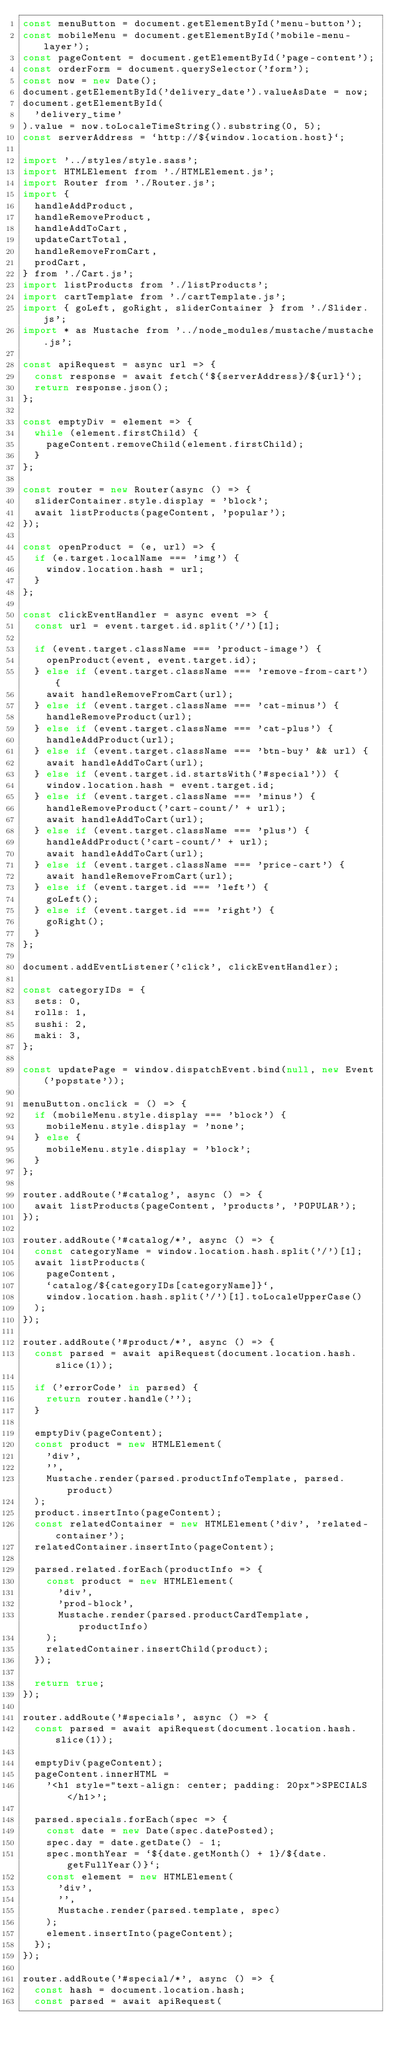<code> <loc_0><loc_0><loc_500><loc_500><_JavaScript_>const menuButton = document.getElementById('menu-button');
const mobileMenu = document.getElementById('mobile-menu-layer');
const pageContent = document.getElementById('page-content');
const orderForm = document.querySelector('form');
const now = new Date();
document.getElementById('delivery_date').valueAsDate = now;
document.getElementById(
  'delivery_time'
).value = now.toLocaleTimeString().substring(0, 5);
const serverAddress = `http://${window.location.host}`;

import '../styles/style.sass';
import HTMLElement from './HTMLElement.js';
import Router from './Router.js';
import {
  handleAddProduct,
  handleRemoveProduct,
  handleAddToCart,
  updateCartTotal,
  handleRemoveFromCart,
  prodCart,
} from './Cart.js';
import listProducts from './listProducts';
import cartTemplate from './cartTemplate.js';
import { goLeft, goRight, sliderContainer } from './Slider.js';
import * as Mustache from '../node_modules/mustache/mustache.js';

const apiRequest = async url => {
  const response = await fetch(`${serverAddress}/${url}`);
  return response.json();
};

const emptyDiv = element => {
  while (element.firstChild) {
    pageContent.removeChild(element.firstChild);
  }
};

const router = new Router(async () => {
  sliderContainer.style.display = 'block';
  await listProducts(pageContent, 'popular');
});

const openProduct = (e, url) => {
  if (e.target.localName === 'img') {
    window.location.hash = url;
  }
};

const clickEventHandler = async event => {
  const url = event.target.id.split('/')[1];

  if (event.target.className === 'product-image') {
    openProduct(event, event.target.id);
  } else if (event.target.className === 'remove-from-cart') {
    await handleRemoveFromCart(url);
  } else if (event.target.className === 'cat-minus') {
    handleRemoveProduct(url);
  } else if (event.target.className === 'cat-plus') {
    handleAddProduct(url);
  } else if (event.target.className === 'btn-buy' && url) {
    await handleAddToCart(url);
  } else if (event.target.id.startsWith('#special')) {
    window.location.hash = event.target.id;
  } else if (event.target.className === 'minus') {
    handleRemoveProduct('cart-count/' + url);
    await handleAddToCart(url);
  } else if (event.target.className === 'plus') {
    handleAddProduct('cart-count/' + url);
    await handleAddToCart(url);
  } else if (event.target.className === 'price-cart') {
    await handleRemoveFromCart(url);
  } else if (event.target.id === 'left') {
    goLeft();
  } else if (event.target.id === 'right') {
    goRight();
  }
};

document.addEventListener('click', clickEventHandler);

const categoryIDs = {
  sets: 0,
  rolls: 1,
  sushi: 2,
  maki: 3,
};

const updatePage = window.dispatchEvent.bind(null, new Event('popstate'));

menuButton.onclick = () => {
  if (mobileMenu.style.display === 'block') {
    mobileMenu.style.display = 'none';
  } else {
    mobileMenu.style.display = 'block';
  }
};

router.addRoute('#catalog', async () => {
  await listProducts(pageContent, 'products', 'POPULAR');
});

router.addRoute('#catalog/*', async () => {
  const categoryName = window.location.hash.split('/')[1];
  await listProducts(
    pageContent,
    `catalog/${categoryIDs[categoryName]}`,
    window.location.hash.split('/')[1].toLocaleUpperCase()
  );
});

router.addRoute('#product/*', async () => {
  const parsed = await apiRequest(document.location.hash.slice(1));

  if ('errorCode' in parsed) {
    return router.handle('');
  }

  emptyDiv(pageContent);
  const product = new HTMLElement(
    'div',
    '',
    Mustache.render(parsed.productInfoTemplate, parsed.product)
  );
  product.insertInto(pageContent);
  const relatedContainer = new HTMLElement('div', 'related-container');
  relatedContainer.insertInto(pageContent);

  parsed.related.forEach(productInfo => {
    const product = new HTMLElement(
      'div',
      'prod-block',
      Mustache.render(parsed.productCardTemplate, productInfo)
    );
    relatedContainer.insertChild(product);
  });

  return true;
});

router.addRoute('#specials', async () => {
  const parsed = await apiRequest(document.location.hash.slice(1));

  emptyDiv(pageContent);
  pageContent.innerHTML =
    '<h1 style="text-align: center; padding: 20px">SPECIALS</h1>';

  parsed.specials.forEach(spec => {
    const date = new Date(spec.datePosted);
    spec.day = date.getDate() - 1;
    spec.monthYear = `${date.getMonth() + 1}/${date.getFullYear()}`;
    const element = new HTMLElement(
      'div',
      '',
      Mustache.render(parsed.template, spec)
    );
    element.insertInto(pageContent);
  });
});

router.addRoute('#special/*', async () => {
  const hash = document.location.hash;
  const parsed = await apiRequest(</code> 